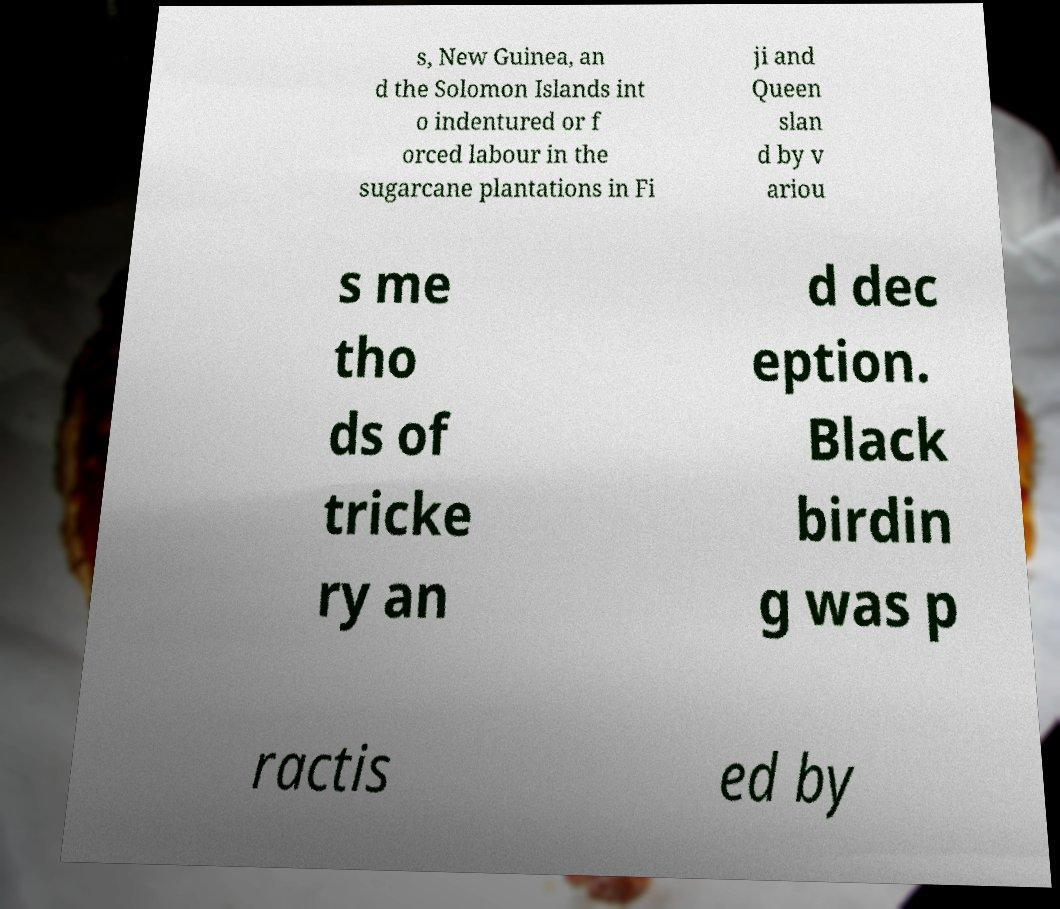What messages or text are displayed in this image? I need them in a readable, typed format. s, New Guinea, an d the Solomon Islands int o indentured or f orced labour in the sugarcane plantations in Fi ji and Queen slan d by v ariou s me tho ds of tricke ry an d dec eption. Black birdin g was p ractis ed by 